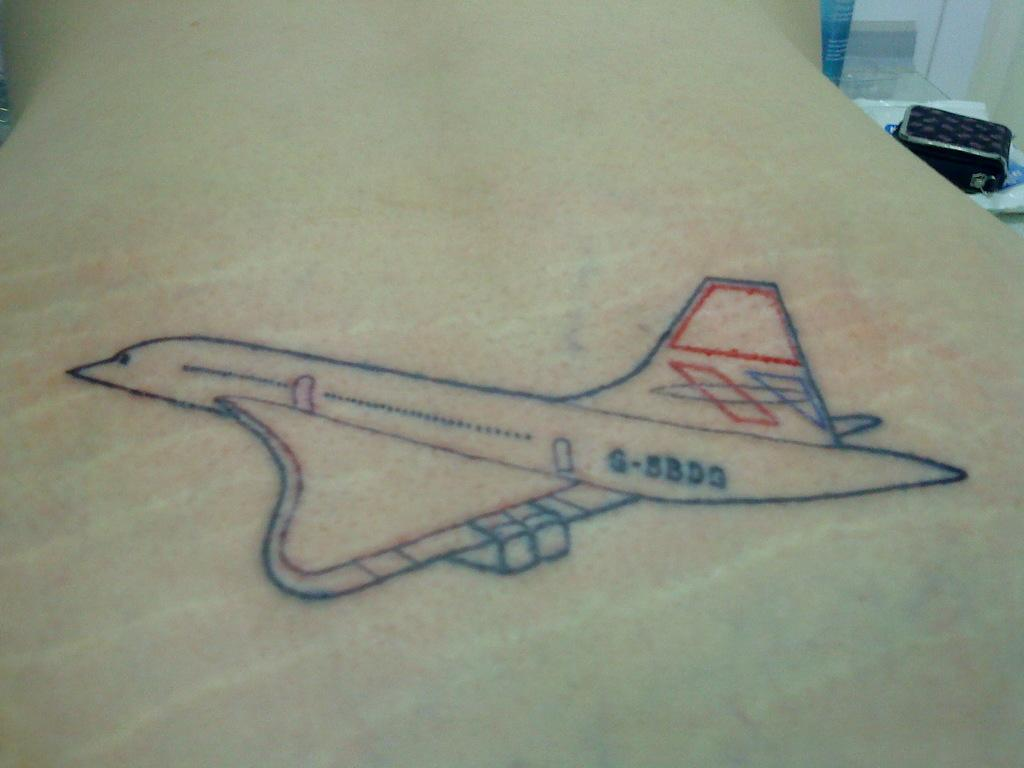<image>
Summarize the visual content of the image. A Space Shuttle drawing includes the number G-5BD3 on it. 